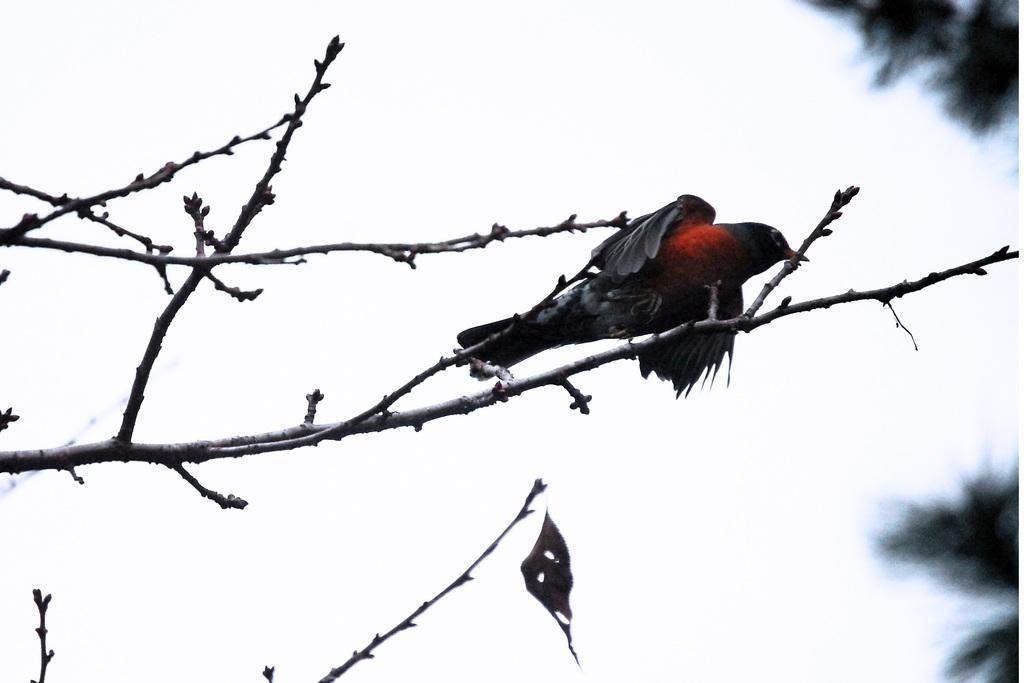How would you summarize this image in a sentence or two? In this picture there is a bird on the tree branch. On the right I can see the trees. In the back I can see the sky. 